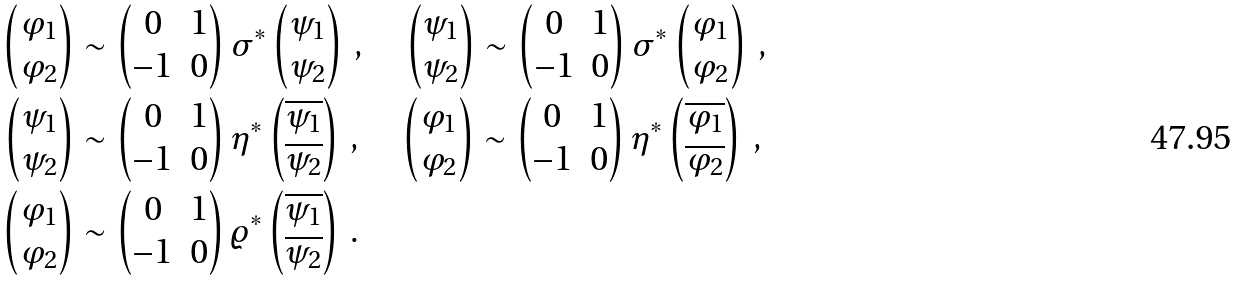Convert formula to latex. <formula><loc_0><loc_0><loc_500><loc_500>\begin{pmatrix} \varphi _ { 1 } \\ \varphi _ { 2 } \end{pmatrix} & \sim \begin{pmatrix} 0 & 1 \\ - 1 & 0 \end{pmatrix} \sigma ^ { * } \begin{pmatrix} \psi _ { 1 } \\ \psi _ { 2 } \end{pmatrix} \, , \quad \begin{pmatrix} \psi _ { 1 } \\ \psi _ { 2 } \end{pmatrix} \sim \begin{pmatrix} 0 & 1 \\ - 1 & 0 \end{pmatrix} \sigma ^ { * } \begin{pmatrix} \varphi _ { 1 } \\ \varphi _ { 2 } \end{pmatrix} \, , \\ \begin{pmatrix} \psi _ { 1 } \\ \psi _ { 2 } \end{pmatrix} & \sim \begin{pmatrix} 0 & 1 \\ - 1 & 0 \end{pmatrix} \eta ^ { * } \begin{pmatrix} \overline { \psi _ { 1 } } \\ \overline { \psi _ { 2 } } \end{pmatrix} \, , \quad \begin{pmatrix} \varphi _ { 1 } \\ \varphi _ { 2 } \end{pmatrix} \sim \begin{pmatrix} 0 & 1 \\ - 1 & 0 \end{pmatrix} \eta ^ { * } \begin{pmatrix} \overline { \varphi _ { 1 } } \\ \overline { \varphi _ { 2 } } \end{pmatrix} \, , \\ \begin{pmatrix} \varphi _ { 1 } \\ \varphi _ { 2 } \end{pmatrix} & \sim \begin{pmatrix} 0 & 1 \\ - 1 & 0 \end{pmatrix} \varrho ^ { * } \begin{pmatrix} \overline { \psi _ { 1 } } \\ \overline { \psi _ { 2 } } \end{pmatrix} \, .</formula> 